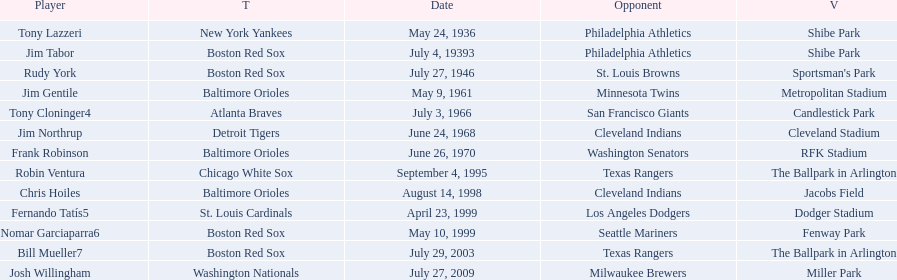Who were all the teams? New York Yankees, Boston Red Sox, Boston Red Sox, Baltimore Orioles, Atlanta Braves, Detroit Tigers, Baltimore Orioles, Chicago White Sox, Baltimore Orioles, St. Louis Cardinals, Boston Red Sox, Boston Red Sox, Washington Nationals. What about opponents? Philadelphia Athletics, Philadelphia Athletics, St. Louis Browns, Minnesota Twins, San Francisco Giants, Cleveland Indians, Washington Senators, Texas Rangers, Cleveland Indians, Los Angeles Dodgers, Seattle Mariners, Texas Rangers, Milwaukee Brewers. Help me parse the entirety of this table. {'header': ['Player', 'T', 'Date', 'Opponent', 'V'], 'rows': [['Tony Lazzeri', 'New York Yankees', 'May 24, 1936', 'Philadelphia Athletics', 'Shibe Park'], ['Jim Tabor', 'Boston Red Sox', 'July 4, 19393', 'Philadelphia Athletics', 'Shibe Park'], ['Rudy York', 'Boston Red Sox', 'July 27, 1946', 'St. Louis Browns', "Sportsman's Park"], ['Jim Gentile', 'Baltimore Orioles', 'May 9, 1961', 'Minnesota Twins', 'Metropolitan Stadium'], ['Tony Cloninger4', 'Atlanta Braves', 'July 3, 1966', 'San Francisco Giants', 'Candlestick Park'], ['Jim Northrup', 'Detroit Tigers', 'June 24, 1968', 'Cleveland Indians', 'Cleveland Stadium'], ['Frank Robinson', 'Baltimore Orioles', 'June 26, 1970', 'Washington Senators', 'RFK Stadium'], ['Robin Ventura', 'Chicago White Sox', 'September 4, 1995', 'Texas Rangers', 'The Ballpark in Arlington'], ['Chris Hoiles', 'Baltimore Orioles', 'August 14, 1998', 'Cleveland Indians', 'Jacobs Field'], ['Fernando Tatís5', 'St. Louis Cardinals', 'April 23, 1999', 'Los Angeles Dodgers', 'Dodger Stadium'], ['Nomar Garciaparra6', 'Boston Red Sox', 'May 10, 1999', 'Seattle Mariners', 'Fenway Park'], ['Bill Mueller7', 'Boston Red Sox', 'July 29, 2003', 'Texas Rangers', 'The Ballpark in Arlington'], ['Josh Willingham', 'Washington Nationals', 'July 27, 2009', 'Milwaukee Brewers', 'Miller Park']]} And when did they play? May 24, 1936, July 4, 19393, July 27, 1946, May 9, 1961, July 3, 1966, June 24, 1968, June 26, 1970, September 4, 1995, August 14, 1998, April 23, 1999, May 10, 1999, July 29, 2003, July 27, 2009. Which team played the red sox on july 27, 1946	? St. Louis Browns. 